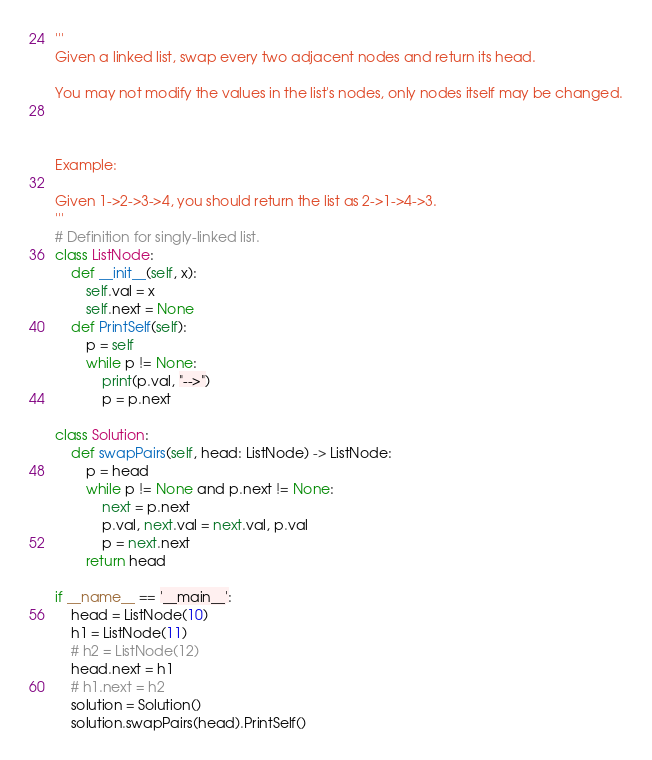<code> <loc_0><loc_0><loc_500><loc_500><_Python_>'''
Given a linked list, swap every two adjacent nodes and return its head.

You may not modify the values in the list's nodes, only nodes itself may be changed.

 

Example:

Given 1->2->3->4, you should return the list as 2->1->4->3.
'''
# Definition for singly-linked list.
class ListNode:
    def __init__(self, x):
        self.val = x
        self.next = None
    def PrintSelf(self):
        p = self
        while p != None:
            print(p.val, "-->")
            p = p.next

class Solution:
    def swapPairs(self, head: ListNode) -> ListNode:
        p = head
        while p != None and p.next != None:
            next = p.next
            p.val, next.val = next.val, p.val
            p = next.next
        return head

if __name__ == '__main__':
    head = ListNode(10)
    h1 = ListNode(11)
    # h2 = ListNode(12)
    head.next = h1
    # h1.next = h2
    solution = Solution()
    solution.swapPairs(head).PrintSelf()</code> 